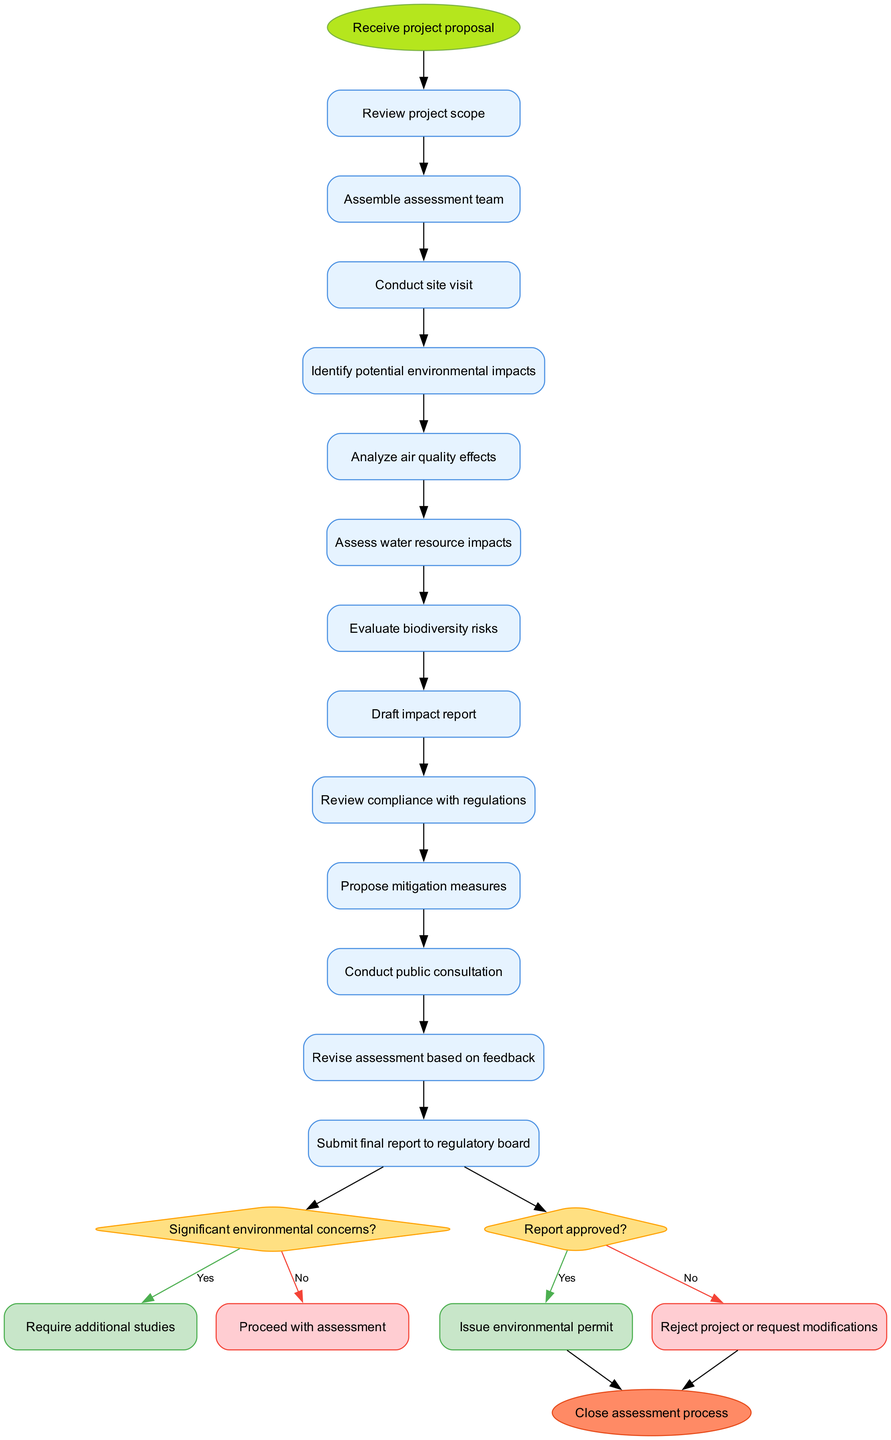What is the initial activity in the process? The diagram starts with the initial node labeled "Receive project proposal." This indicates the very first step in the environmental impact assessment process as depicted in the activity diagram.
Answer: Receive project proposal How many activities are there in total? The diagram lists a total of 12 distinct activities involved in the environmental impact assessment process. This number can be verified by counting the activities in the provided data.
Answer: 12 What happens if there are significant environmental concerns? If there are significant environmental concerns identified, the process will require additional studies as indicated in the decision node labeled "Significant environmental concerns?" which has a "yes" branch leading to that outcome.
Answer: Require additional studies What is the final outcome of the assessment process? The final node in the diagram is labeled "Close assessment process," indicating that this is the last step to be taken after all evaluations and decisions are made in the assessment process.
Answer: Close assessment process Which activity directly follows the "Conduct site visit"? After the activity "Conduct site visit," the next activity is "Identify potential environmental impacts." This step represents a direct connection in the flow of the assessment process following the site visit.
Answer: Identify potential environmental impacts What occurs if the report is not approved? If the report is not approved, the process indicates either to reject the project or request modifications as shown in the decision node labeled "Report approved?" which has a "no" branch pointing to this outcome.
Answer: Reject project or request modifications How many decision nodes are present in the diagram? The diagram contains 2 decision nodes which are specifically marked for making critical yes/no assessments in the environmental impact process. This can be confirmed by counting the decision nodes listed in the data.
Answer: 2 What is evaluated to assess water resource impacts? The assessment process includes a specific activity labeled "Assess water resource impacts," highlighting the dedicated evaluation of this environmental factor.
Answer: Assess water resource impacts What is the last activity before submitting the final report? The last activity prior to submitting the final report is "Revise assessment based on feedback," indicating that revisions are made based on public consultations and regulatory input before finalization.
Answer: Revise assessment based on feedback 